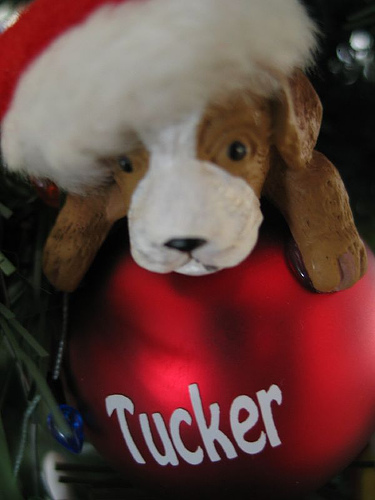<image>
Is the dog behind the hat? No. The dog is not behind the hat. From this viewpoint, the dog appears to be positioned elsewhere in the scene. Is there a dog on the ornament? Yes. Looking at the image, I can see the dog is positioned on top of the ornament, with the ornament providing support. 